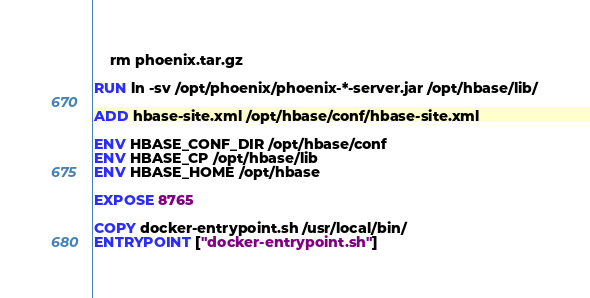<code> <loc_0><loc_0><loc_500><loc_500><_Dockerfile_>    rm phoenix.tar.gz

RUN ln -sv /opt/phoenix/phoenix-*-server.jar /opt/hbase/lib/

ADD hbase-site.xml /opt/hbase/conf/hbase-site.xml

ENV HBASE_CONF_DIR /opt/hbase/conf
ENV HBASE_CP /opt/hbase/lib
ENV HBASE_HOME /opt/hbase

EXPOSE 8765

COPY docker-entrypoint.sh /usr/local/bin/
ENTRYPOINT ["docker-entrypoint.sh"]
</code> 